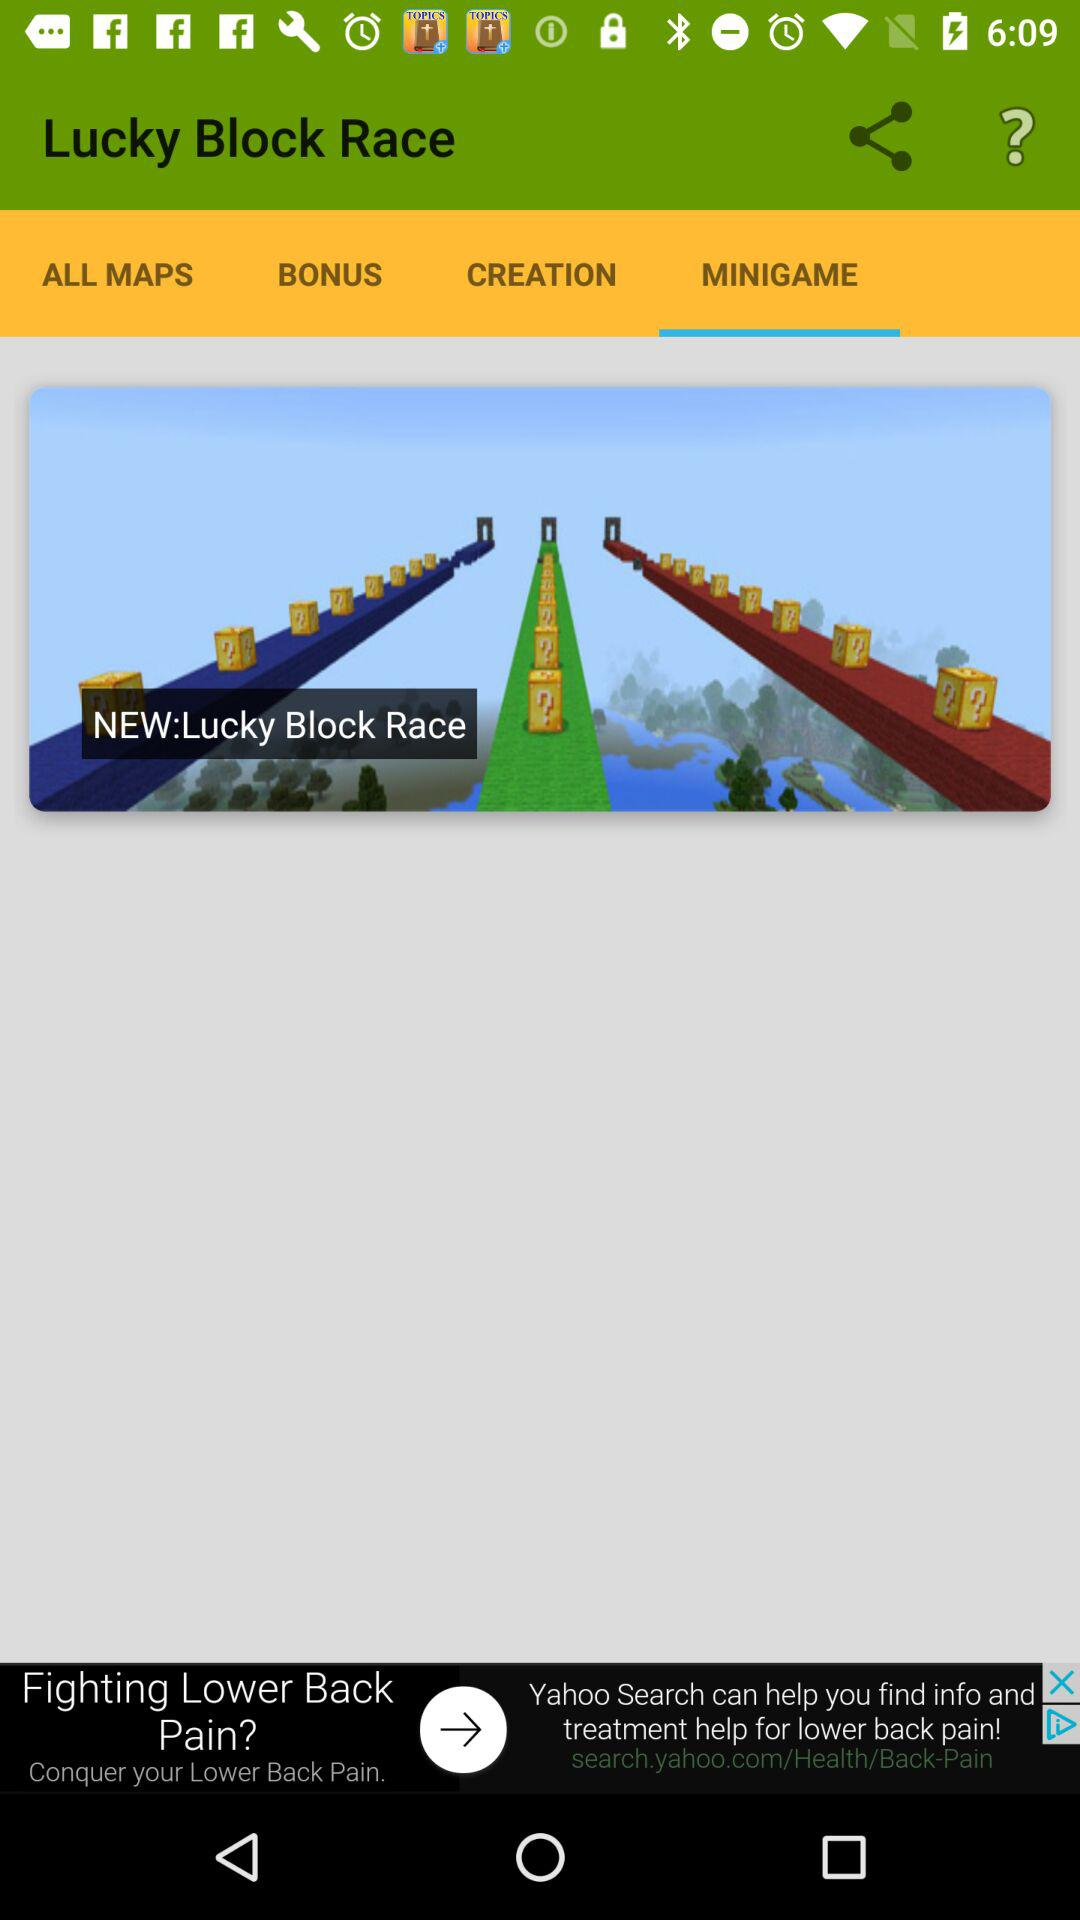Which tab is selected? The selected tab is "MINIGAME". 